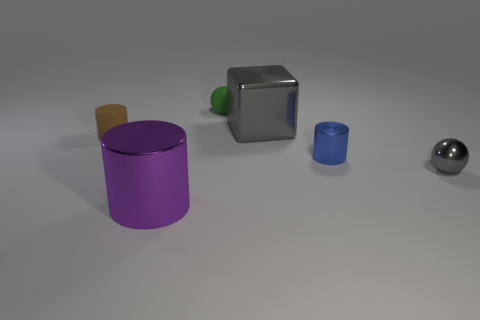Add 1 big blue objects. How many objects exist? 7 Subtract all cubes. How many objects are left? 5 Subtract all metallic cylinders. Subtract all cyan metallic cylinders. How many objects are left? 4 Add 5 metallic cylinders. How many metallic cylinders are left? 7 Add 2 large metallic things. How many large metallic things exist? 4 Subtract 0 purple spheres. How many objects are left? 6 